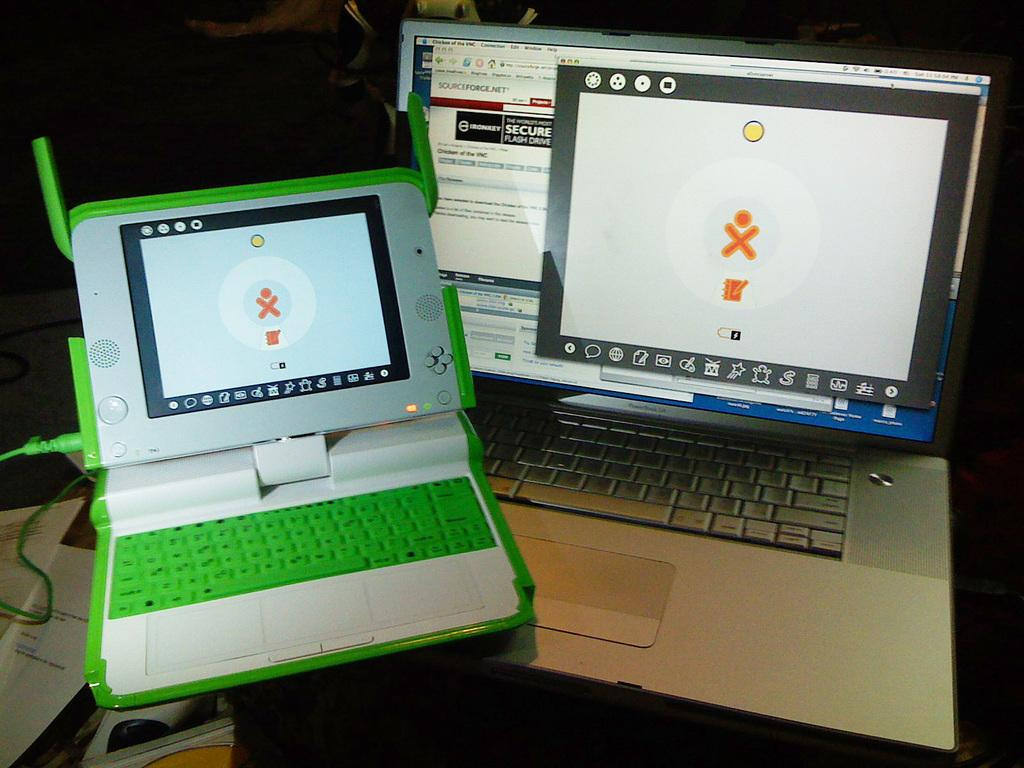<image>
Offer a succinct explanation of the picture presented. A silver laptop has a window with the word Secure near the top. 